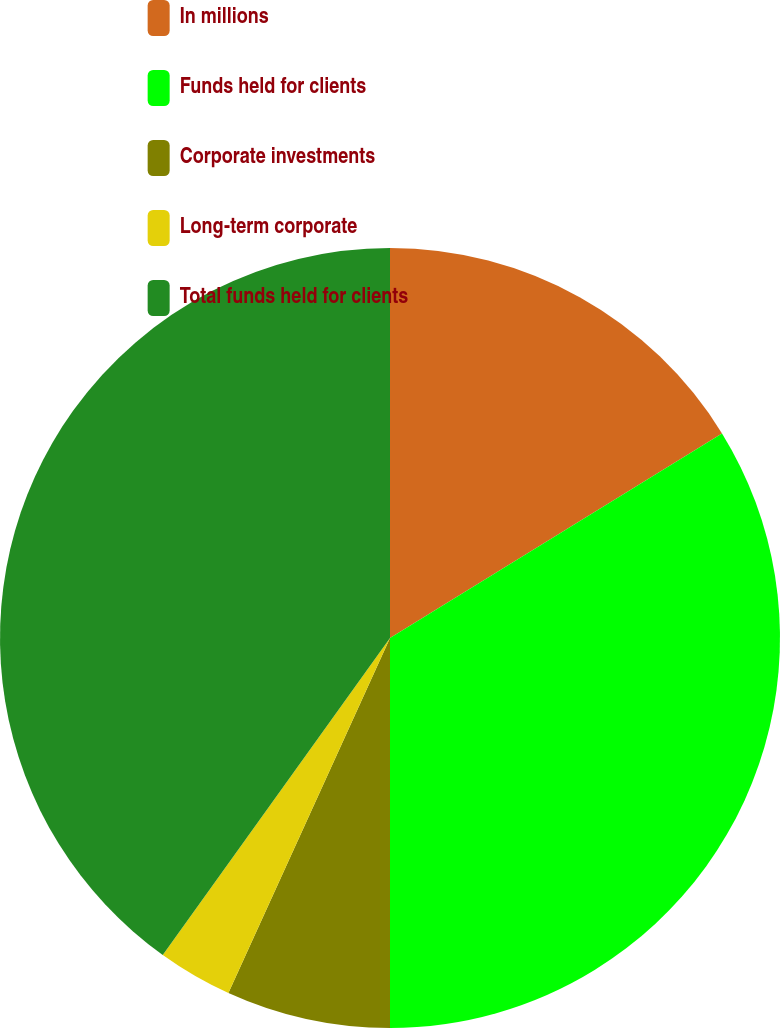Convert chart to OTSL. <chart><loc_0><loc_0><loc_500><loc_500><pie_chart><fcel>In millions<fcel>Funds held for clients<fcel>Corporate investments<fcel>Long-term corporate<fcel>Total funds held for clients<nl><fcel>16.21%<fcel>33.79%<fcel>6.8%<fcel>3.1%<fcel>40.1%<nl></chart> 